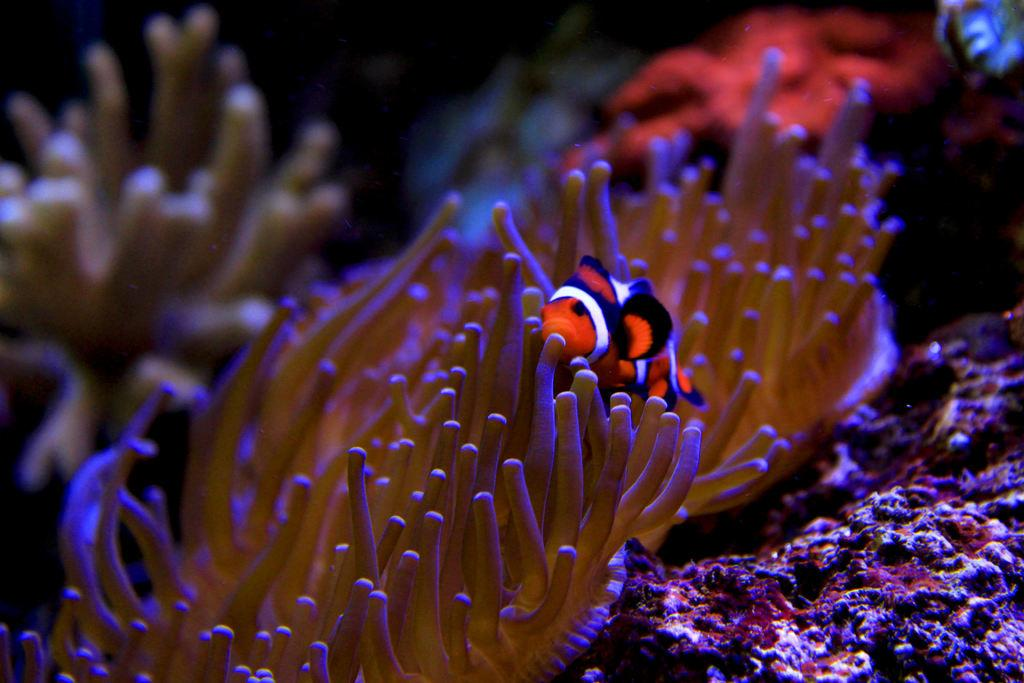What type of animal is in the image? There is a small fish in the image. What is the fish doing in the image? The fish is swimming beside plants. Where is the fish located in the image? The fish is swimming in water that is underground. What type of quill can be seen in the image? There is no quill present in the image; it features a small fish swimming beside plants in underground water. 